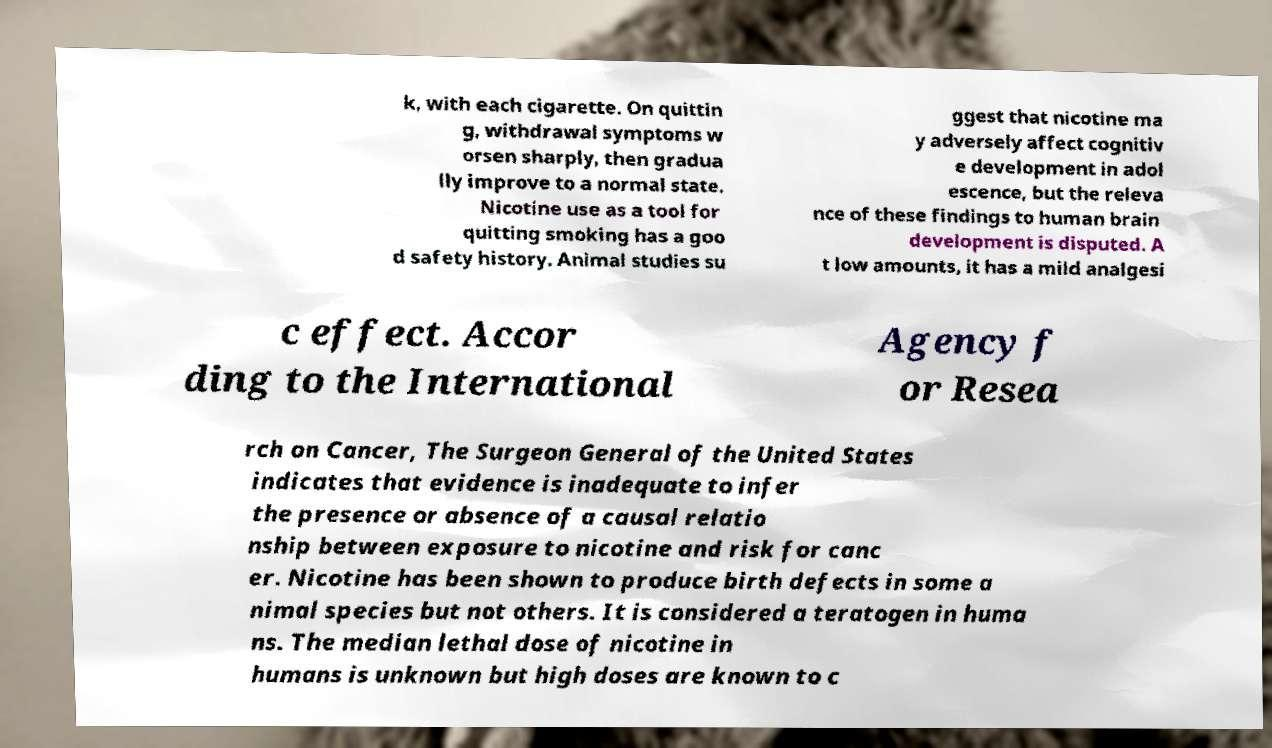What messages or text are displayed in this image? I need them in a readable, typed format. k, with each cigarette. On quittin g, withdrawal symptoms w orsen sharply, then gradua lly improve to a normal state. Nicotine use as a tool for quitting smoking has a goo d safety history. Animal studies su ggest that nicotine ma y adversely affect cognitiv e development in adol escence, but the releva nce of these findings to human brain development is disputed. A t low amounts, it has a mild analgesi c effect. Accor ding to the International Agency f or Resea rch on Cancer, The Surgeon General of the United States indicates that evidence is inadequate to infer the presence or absence of a causal relatio nship between exposure to nicotine and risk for canc er. Nicotine has been shown to produce birth defects in some a nimal species but not others. It is considered a teratogen in huma ns. The median lethal dose of nicotine in humans is unknown but high doses are known to c 